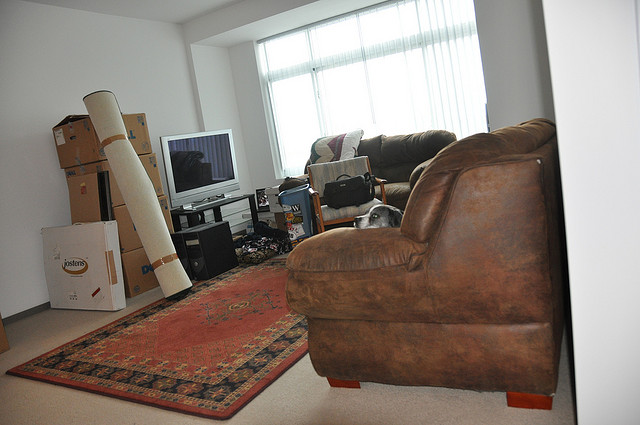Please transcribe the text in this image. jostens 